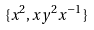Convert formula to latex. <formula><loc_0><loc_0><loc_500><loc_500>\{ x ^ { 2 } , x y ^ { 2 } x ^ { - 1 } \}</formula> 